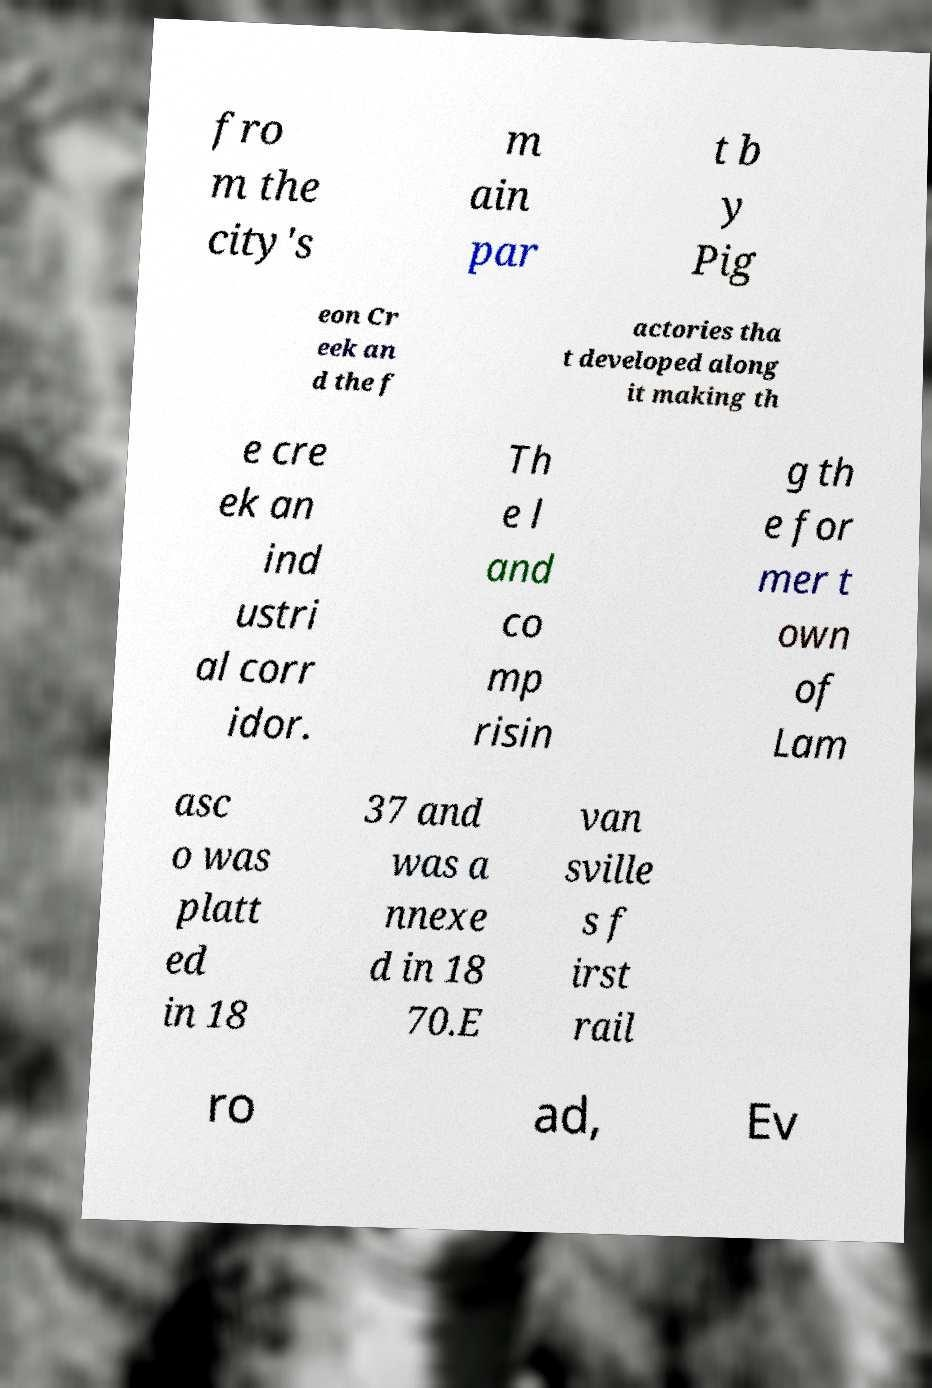What messages or text are displayed in this image? I need them in a readable, typed format. fro m the city's m ain par t b y Pig eon Cr eek an d the f actories tha t developed along it making th e cre ek an ind ustri al corr idor. Th e l and co mp risin g th e for mer t own of Lam asc o was platt ed in 18 37 and was a nnexe d in 18 70.E van sville s f irst rail ro ad, Ev 